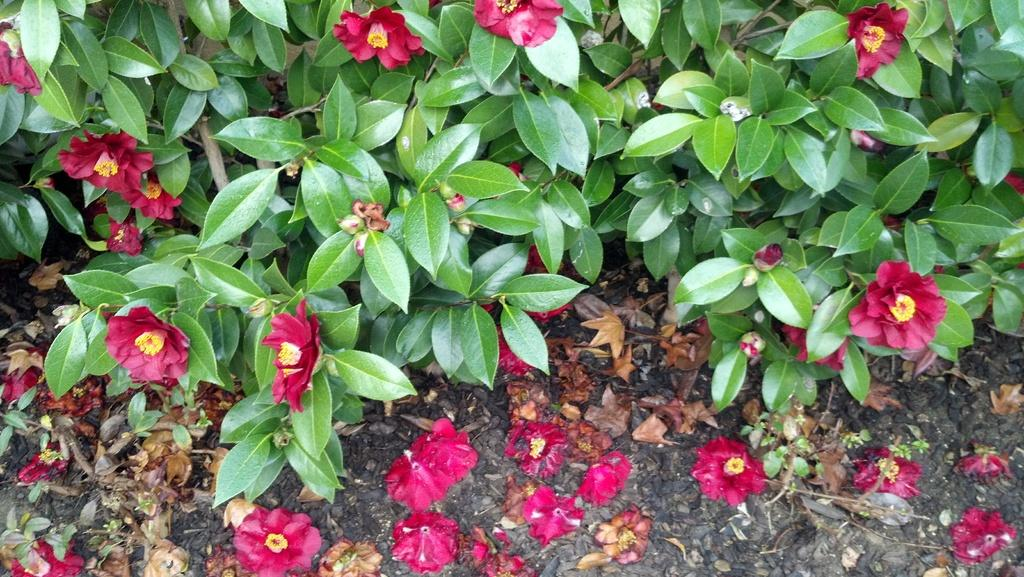What type of plants are visible in the image? There are plants with flowers in the image. What parts of the plants can be seen in the image? There are leaves in the image. Where are some of the flowers and leaves located? Some flowers and leaves are on the ground. What type of sock is hanging from the tree in the image? There is no sock present in the image; it features plants with flowers and leaves. 